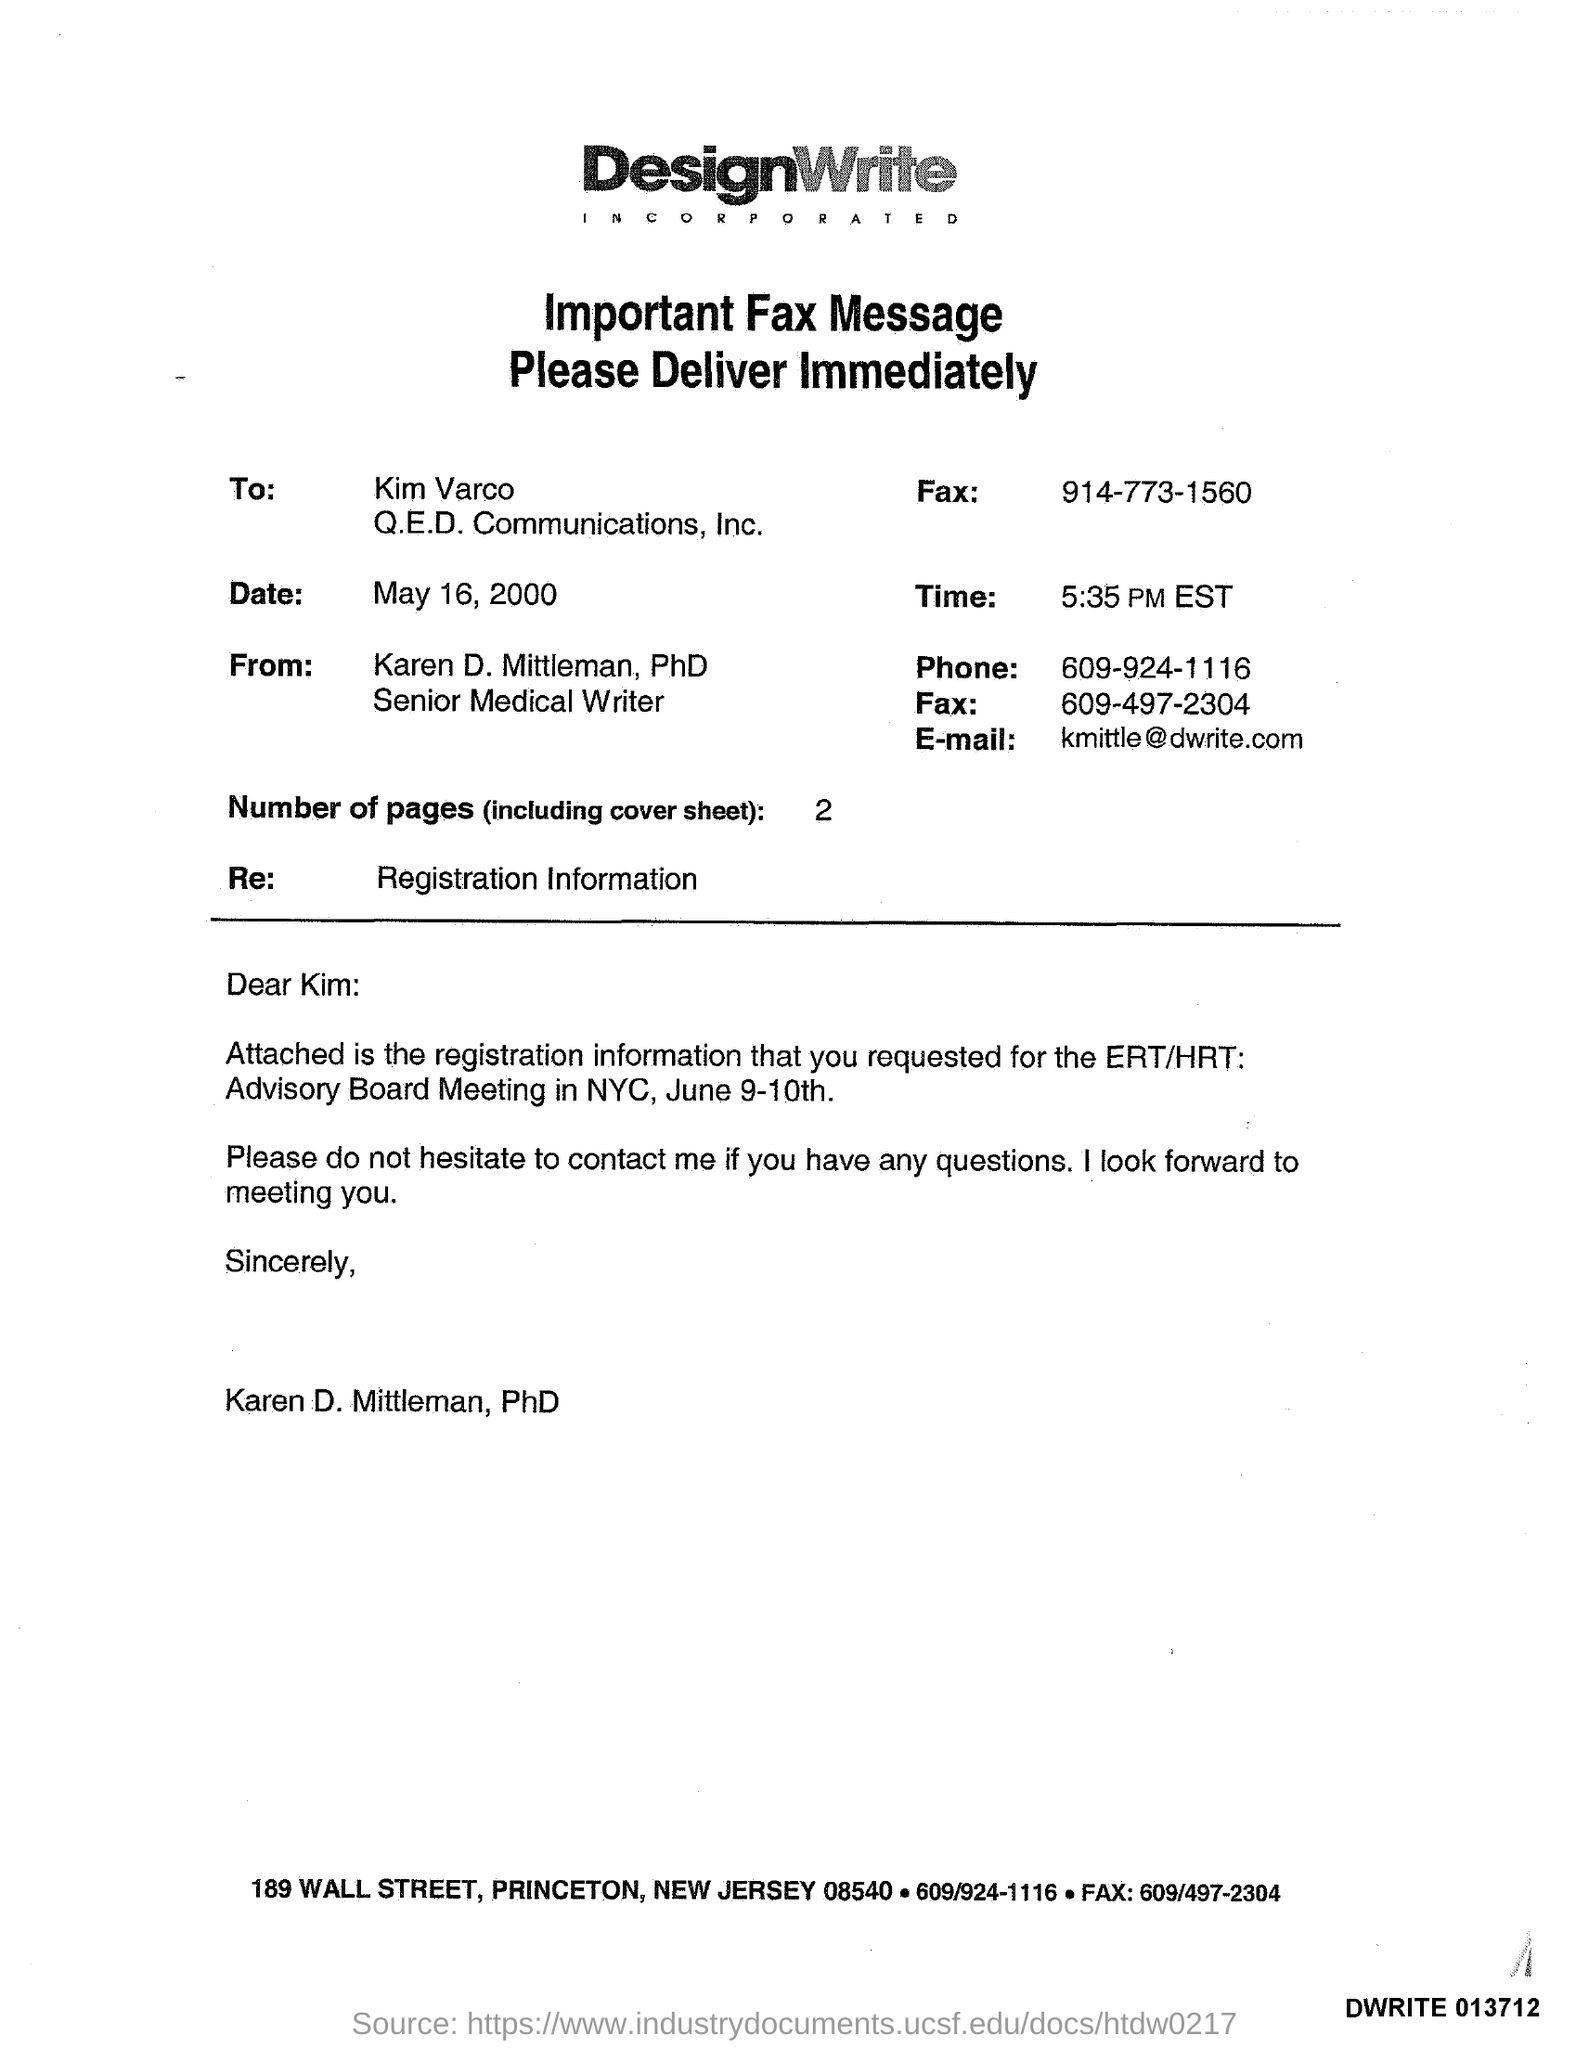To whom this fax was sent ?
Ensure brevity in your answer.  Kim Varco. What is the time mentioned in the given fax message ?
Provide a short and direct response. 5:35 PM EST. What is the date mentioned in the fax message ?
Provide a short and direct response. May 16, 2000. From whom this fax message was delivered ?
Ensure brevity in your answer.  Karen D. Mittleman, PhD Senior Medical Writer. What is the phone number mentioned in the fax message ?
Keep it short and to the point. 609-924-1116. How many number of pages are there (including cover sheet )?
Ensure brevity in your answer.  2. What is the e-mail mentioned in the given fax message ?
Provide a short and direct response. Kmittle@dwrite.com. What is the designation of karen d. mittleman ?
Offer a terse response. Senior Medical Writer. What is the re mentioned in the given fax message ?
Make the answer very short. Registration Information. 